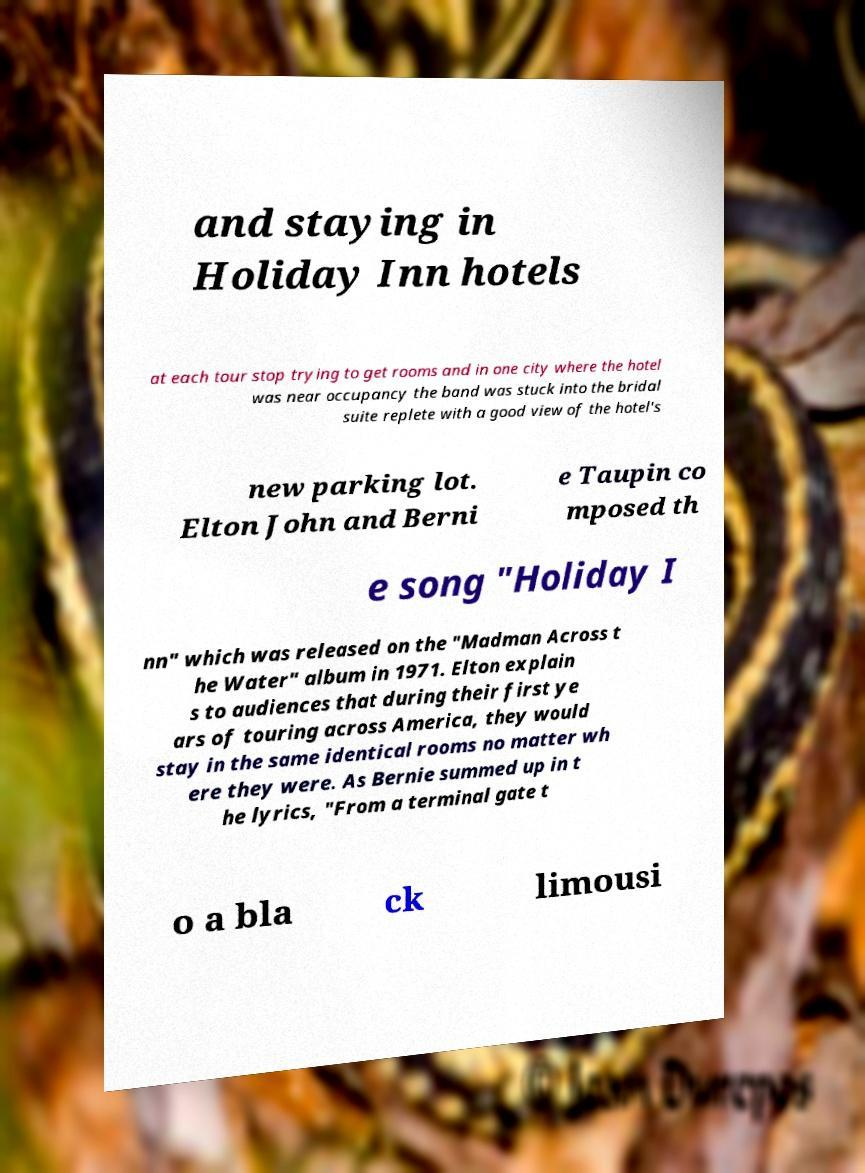I need the written content from this picture converted into text. Can you do that? and staying in Holiday Inn hotels at each tour stop trying to get rooms and in one city where the hotel was near occupancy the band was stuck into the bridal suite replete with a good view of the hotel's new parking lot. Elton John and Berni e Taupin co mposed th e song "Holiday I nn" which was released on the "Madman Across t he Water" album in 1971. Elton explain s to audiences that during their first ye ars of touring across America, they would stay in the same identical rooms no matter wh ere they were. As Bernie summed up in t he lyrics, "From a terminal gate t o a bla ck limousi 